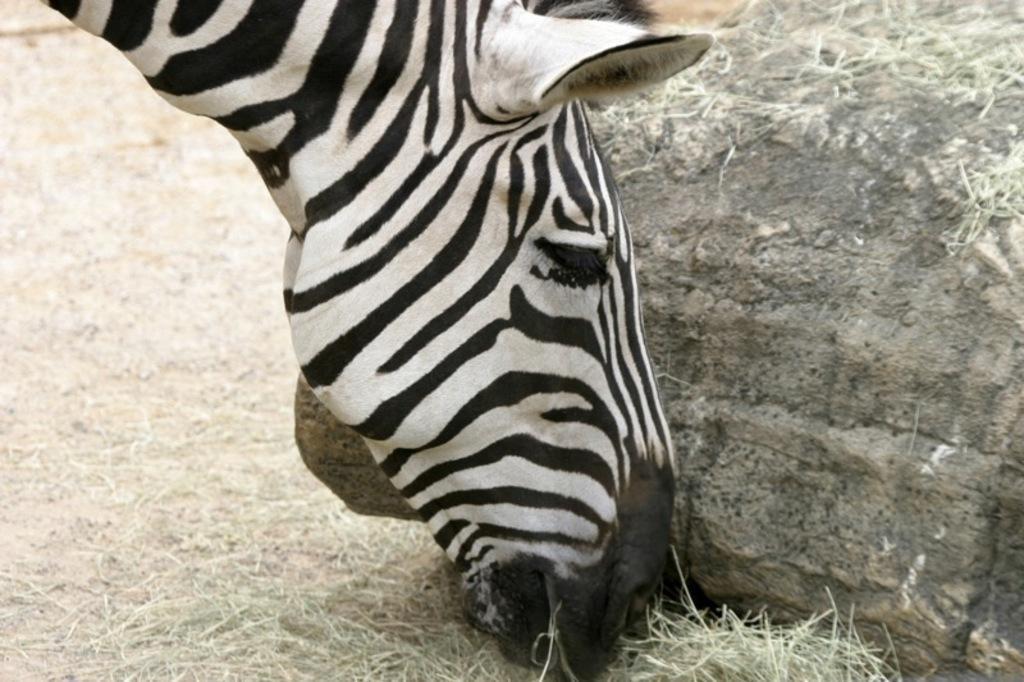How would you summarize this image in a sentence or two? In this image we can see an animal. We can see the grass in the image. There is a rock at the right side of the image. 